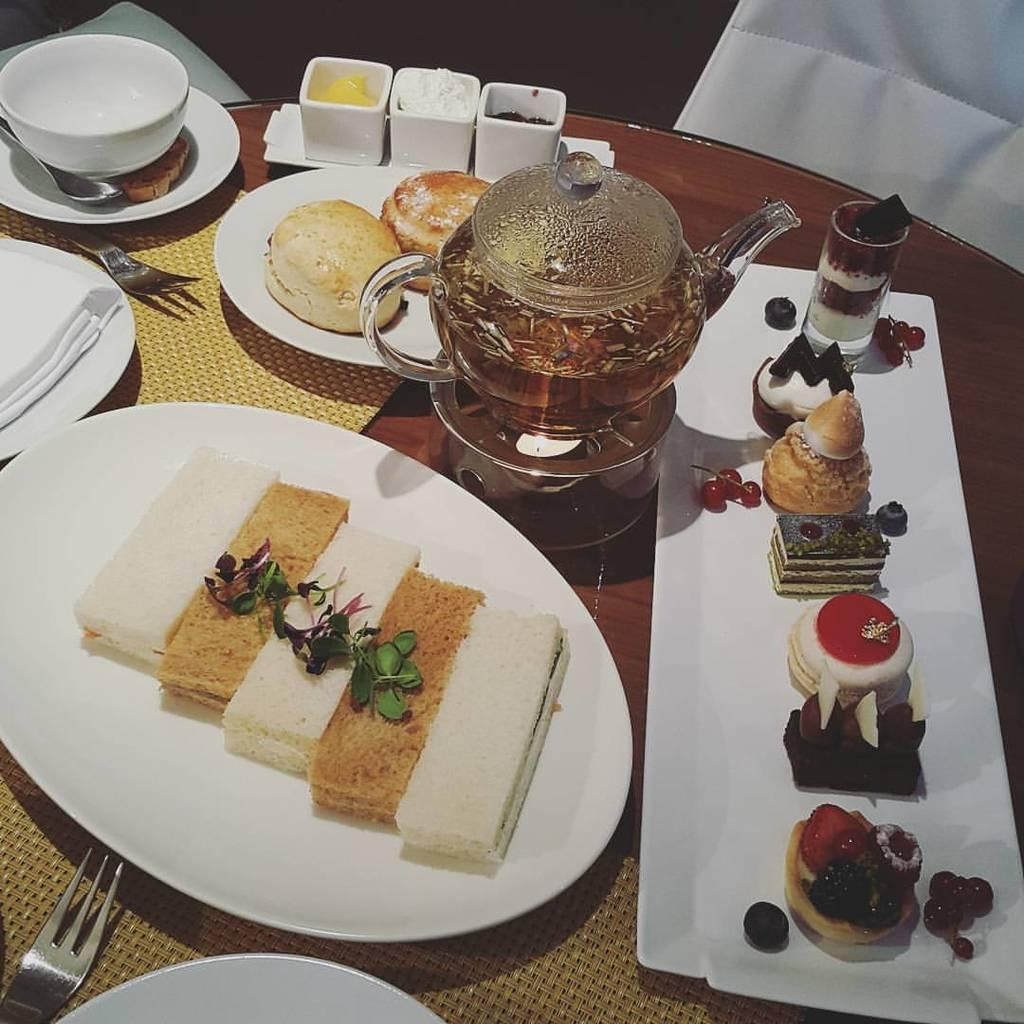What type of tableware can be seen in the image? There are plates, forks, bowls, and glasses in the image. What else is present on the table in the image? There is food on the table in the image. What additional item can be found in the image? There is a kettle in the image. What might be used for cleaning or wiping in the image? There are tissues in the image. What type of seating is visible behind the table in the image? There are white chairs behind the table in the image. Can you tell me how many ships are docked behind the table in the image? There are no ships present in the image; it features a table with tableware, food, a kettle, tissues, and white chairs behind it. What level of comfort can be observed in the image? The image does not provide information about the comfort level of the seating or any other aspect of the scene. 